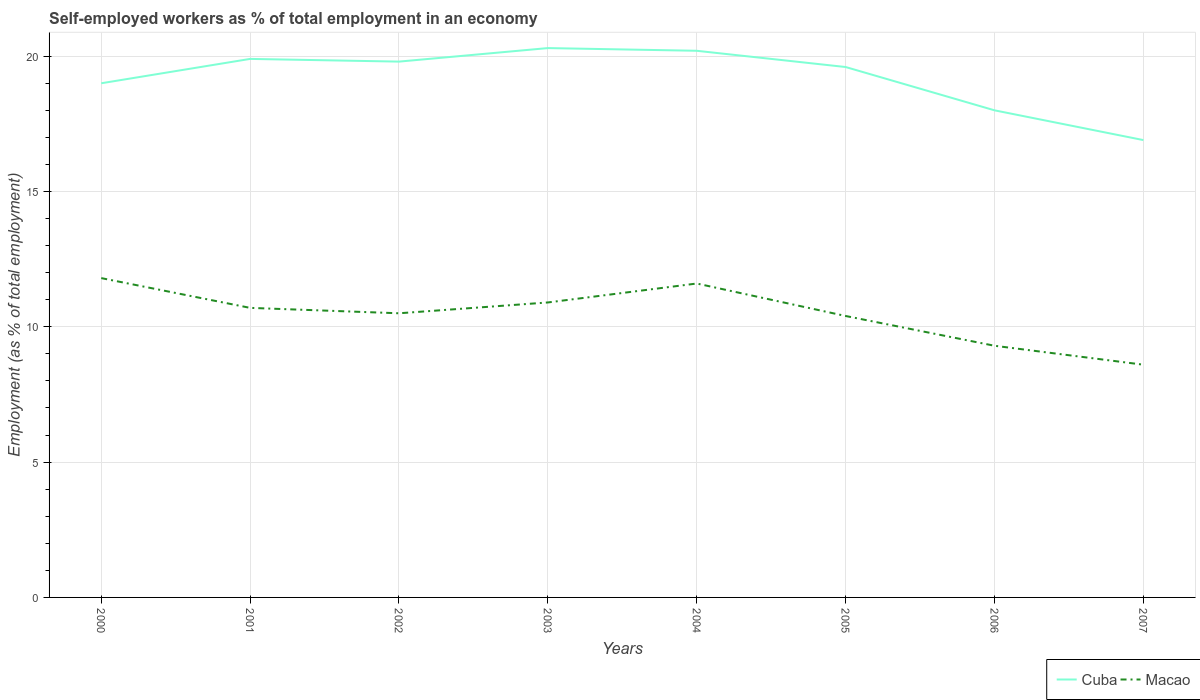How many different coloured lines are there?
Your response must be concise. 2. Does the line corresponding to Cuba intersect with the line corresponding to Macao?
Offer a terse response. No. Across all years, what is the maximum percentage of self-employed workers in Macao?
Your response must be concise. 8.6. In which year was the percentage of self-employed workers in Cuba maximum?
Make the answer very short. 2007. What is the total percentage of self-employed workers in Cuba in the graph?
Provide a succinct answer. -0.6. What is the difference between the highest and the second highest percentage of self-employed workers in Macao?
Ensure brevity in your answer.  3.2. Is the percentage of self-employed workers in Macao strictly greater than the percentage of self-employed workers in Cuba over the years?
Your answer should be compact. Yes. How many lines are there?
Offer a very short reply. 2. How many years are there in the graph?
Your response must be concise. 8. What is the difference between two consecutive major ticks on the Y-axis?
Your response must be concise. 5. How many legend labels are there?
Your answer should be compact. 2. What is the title of the graph?
Your answer should be very brief. Self-employed workers as % of total employment in an economy. What is the label or title of the Y-axis?
Your response must be concise. Employment (as % of total employment). What is the Employment (as % of total employment) of Macao in 2000?
Keep it short and to the point. 11.8. What is the Employment (as % of total employment) of Cuba in 2001?
Make the answer very short. 19.9. What is the Employment (as % of total employment) in Macao in 2001?
Give a very brief answer. 10.7. What is the Employment (as % of total employment) of Cuba in 2002?
Your response must be concise. 19.8. What is the Employment (as % of total employment) of Macao in 2002?
Your answer should be very brief. 10.5. What is the Employment (as % of total employment) in Cuba in 2003?
Your response must be concise. 20.3. What is the Employment (as % of total employment) of Macao in 2003?
Keep it short and to the point. 10.9. What is the Employment (as % of total employment) of Cuba in 2004?
Provide a succinct answer. 20.2. What is the Employment (as % of total employment) of Macao in 2004?
Provide a short and direct response. 11.6. What is the Employment (as % of total employment) in Cuba in 2005?
Your answer should be very brief. 19.6. What is the Employment (as % of total employment) in Macao in 2005?
Offer a very short reply. 10.4. What is the Employment (as % of total employment) in Macao in 2006?
Your answer should be very brief. 9.3. What is the Employment (as % of total employment) in Cuba in 2007?
Give a very brief answer. 16.9. What is the Employment (as % of total employment) of Macao in 2007?
Your response must be concise. 8.6. Across all years, what is the maximum Employment (as % of total employment) in Cuba?
Your response must be concise. 20.3. Across all years, what is the maximum Employment (as % of total employment) in Macao?
Ensure brevity in your answer.  11.8. Across all years, what is the minimum Employment (as % of total employment) of Cuba?
Give a very brief answer. 16.9. Across all years, what is the minimum Employment (as % of total employment) in Macao?
Ensure brevity in your answer.  8.6. What is the total Employment (as % of total employment) of Cuba in the graph?
Your response must be concise. 153.7. What is the total Employment (as % of total employment) of Macao in the graph?
Give a very brief answer. 83.8. What is the difference between the Employment (as % of total employment) of Cuba in 2000 and that in 2004?
Offer a terse response. -1.2. What is the difference between the Employment (as % of total employment) in Macao in 2000 and that in 2004?
Provide a short and direct response. 0.2. What is the difference between the Employment (as % of total employment) of Cuba in 2000 and that in 2007?
Offer a very short reply. 2.1. What is the difference between the Employment (as % of total employment) of Macao in 2001 and that in 2002?
Your answer should be compact. 0.2. What is the difference between the Employment (as % of total employment) in Cuba in 2001 and that in 2003?
Give a very brief answer. -0.4. What is the difference between the Employment (as % of total employment) in Macao in 2001 and that in 2003?
Your answer should be compact. -0.2. What is the difference between the Employment (as % of total employment) in Cuba in 2001 and that in 2004?
Offer a terse response. -0.3. What is the difference between the Employment (as % of total employment) in Macao in 2001 and that in 2004?
Ensure brevity in your answer.  -0.9. What is the difference between the Employment (as % of total employment) in Cuba in 2001 and that in 2006?
Offer a terse response. 1.9. What is the difference between the Employment (as % of total employment) in Cuba in 2001 and that in 2007?
Offer a terse response. 3. What is the difference between the Employment (as % of total employment) of Cuba in 2002 and that in 2004?
Offer a terse response. -0.4. What is the difference between the Employment (as % of total employment) in Cuba in 2002 and that in 2005?
Provide a short and direct response. 0.2. What is the difference between the Employment (as % of total employment) of Macao in 2002 and that in 2005?
Ensure brevity in your answer.  0.1. What is the difference between the Employment (as % of total employment) in Macao in 2002 and that in 2006?
Offer a very short reply. 1.2. What is the difference between the Employment (as % of total employment) in Macao in 2002 and that in 2007?
Your response must be concise. 1.9. What is the difference between the Employment (as % of total employment) of Cuba in 2003 and that in 2004?
Offer a terse response. 0.1. What is the difference between the Employment (as % of total employment) of Macao in 2003 and that in 2005?
Offer a terse response. 0.5. What is the difference between the Employment (as % of total employment) in Macao in 2003 and that in 2007?
Your answer should be compact. 2.3. What is the difference between the Employment (as % of total employment) of Macao in 2005 and that in 2006?
Your answer should be very brief. 1.1. What is the difference between the Employment (as % of total employment) of Cuba in 2005 and that in 2007?
Offer a terse response. 2.7. What is the difference between the Employment (as % of total employment) of Macao in 2005 and that in 2007?
Offer a very short reply. 1.8. What is the difference between the Employment (as % of total employment) of Cuba in 2000 and the Employment (as % of total employment) of Macao in 2001?
Ensure brevity in your answer.  8.3. What is the difference between the Employment (as % of total employment) in Cuba in 2000 and the Employment (as % of total employment) in Macao in 2002?
Ensure brevity in your answer.  8.5. What is the difference between the Employment (as % of total employment) of Cuba in 2000 and the Employment (as % of total employment) of Macao in 2005?
Offer a very short reply. 8.6. What is the difference between the Employment (as % of total employment) of Cuba in 2000 and the Employment (as % of total employment) of Macao in 2007?
Offer a terse response. 10.4. What is the difference between the Employment (as % of total employment) in Cuba in 2001 and the Employment (as % of total employment) in Macao in 2002?
Offer a very short reply. 9.4. What is the difference between the Employment (as % of total employment) in Cuba in 2001 and the Employment (as % of total employment) in Macao in 2003?
Make the answer very short. 9. What is the difference between the Employment (as % of total employment) in Cuba in 2001 and the Employment (as % of total employment) in Macao in 2004?
Your answer should be compact. 8.3. What is the difference between the Employment (as % of total employment) in Cuba in 2001 and the Employment (as % of total employment) in Macao in 2005?
Make the answer very short. 9.5. What is the difference between the Employment (as % of total employment) of Cuba in 2001 and the Employment (as % of total employment) of Macao in 2006?
Provide a short and direct response. 10.6. What is the difference between the Employment (as % of total employment) of Cuba in 2001 and the Employment (as % of total employment) of Macao in 2007?
Offer a very short reply. 11.3. What is the difference between the Employment (as % of total employment) of Cuba in 2002 and the Employment (as % of total employment) of Macao in 2006?
Give a very brief answer. 10.5. What is the difference between the Employment (as % of total employment) of Cuba in 2002 and the Employment (as % of total employment) of Macao in 2007?
Offer a terse response. 11.2. What is the difference between the Employment (as % of total employment) of Cuba in 2003 and the Employment (as % of total employment) of Macao in 2004?
Provide a succinct answer. 8.7. What is the difference between the Employment (as % of total employment) of Cuba in 2003 and the Employment (as % of total employment) of Macao in 2007?
Your answer should be very brief. 11.7. What is the difference between the Employment (as % of total employment) in Cuba in 2004 and the Employment (as % of total employment) in Macao in 2005?
Ensure brevity in your answer.  9.8. What is the difference between the Employment (as % of total employment) in Cuba in 2005 and the Employment (as % of total employment) in Macao in 2006?
Ensure brevity in your answer.  10.3. What is the difference between the Employment (as % of total employment) of Cuba in 2005 and the Employment (as % of total employment) of Macao in 2007?
Offer a terse response. 11. What is the difference between the Employment (as % of total employment) in Cuba in 2006 and the Employment (as % of total employment) in Macao in 2007?
Your response must be concise. 9.4. What is the average Employment (as % of total employment) in Cuba per year?
Make the answer very short. 19.21. What is the average Employment (as % of total employment) in Macao per year?
Your answer should be compact. 10.47. In the year 2000, what is the difference between the Employment (as % of total employment) of Cuba and Employment (as % of total employment) of Macao?
Keep it short and to the point. 7.2. In the year 2002, what is the difference between the Employment (as % of total employment) in Cuba and Employment (as % of total employment) in Macao?
Provide a succinct answer. 9.3. In the year 2003, what is the difference between the Employment (as % of total employment) in Cuba and Employment (as % of total employment) in Macao?
Your response must be concise. 9.4. In the year 2004, what is the difference between the Employment (as % of total employment) of Cuba and Employment (as % of total employment) of Macao?
Keep it short and to the point. 8.6. In the year 2006, what is the difference between the Employment (as % of total employment) of Cuba and Employment (as % of total employment) of Macao?
Offer a very short reply. 8.7. In the year 2007, what is the difference between the Employment (as % of total employment) of Cuba and Employment (as % of total employment) of Macao?
Provide a short and direct response. 8.3. What is the ratio of the Employment (as % of total employment) in Cuba in 2000 to that in 2001?
Make the answer very short. 0.95. What is the ratio of the Employment (as % of total employment) of Macao in 2000 to that in 2001?
Make the answer very short. 1.1. What is the ratio of the Employment (as % of total employment) in Cuba in 2000 to that in 2002?
Make the answer very short. 0.96. What is the ratio of the Employment (as % of total employment) of Macao in 2000 to that in 2002?
Offer a terse response. 1.12. What is the ratio of the Employment (as % of total employment) in Cuba in 2000 to that in 2003?
Provide a succinct answer. 0.94. What is the ratio of the Employment (as % of total employment) of Macao in 2000 to that in 2003?
Your answer should be very brief. 1.08. What is the ratio of the Employment (as % of total employment) in Cuba in 2000 to that in 2004?
Offer a terse response. 0.94. What is the ratio of the Employment (as % of total employment) of Macao in 2000 to that in 2004?
Make the answer very short. 1.02. What is the ratio of the Employment (as % of total employment) in Cuba in 2000 to that in 2005?
Make the answer very short. 0.97. What is the ratio of the Employment (as % of total employment) of Macao in 2000 to that in 2005?
Provide a short and direct response. 1.13. What is the ratio of the Employment (as % of total employment) in Cuba in 2000 to that in 2006?
Offer a terse response. 1.06. What is the ratio of the Employment (as % of total employment) in Macao in 2000 to that in 2006?
Provide a succinct answer. 1.27. What is the ratio of the Employment (as % of total employment) of Cuba in 2000 to that in 2007?
Your answer should be very brief. 1.12. What is the ratio of the Employment (as % of total employment) of Macao in 2000 to that in 2007?
Your answer should be very brief. 1.37. What is the ratio of the Employment (as % of total employment) in Cuba in 2001 to that in 2002?
Provide a short and direct response. 1.01. What is the ratio of the Employment (as % of total employment) in Macao in 2001 to that in 2002?
Offer a very short reply. 1.02. What is the ratio of the Employment (as % of total employment) of Cuba in 2001 to that in 2003?
Provide a short and direct response. 0.98. What is the ratio of the Employment (as % of total employment) in Macao in 2001 to that in 2003?
Make the answer very short. 0.98. What is the ratio of the Employment (as % of total employment) in Cuba in 2001 to that in 2004?
Provide a succinct answer. 0.99. What is the ratio of the Employment (as % of total employment) in Macao in 2001 to that in 2004?
Keep it short and to the point. 0.92. What is the ratio of the Employment (as % of total employment) in Cuba in 2001 to that in 2005?
Give a very brief answer. 1.02. What is the ratio of the Employment (as % of total employment) of Macao in 2001 to that in 2005?
Your response must be concise. 1.03. What is the ratio of the Employment (as % of total employment) in Cuba in 2001 to that in 2006?
Ensure brevity in your answer.  1.11. What is the ratio of the Employment (as % of total employment) in Macao in 2001 to that in 2006?
Your response must be concise. 1.15. What is the ratio of the Employment (as % of total employment) of Cuba in 2001 to that in 2007?
Give a very brief answer. 1.18. What is the ratio of the Employment (as % of total employment) in Macao in 2001 to that in 2007?
Your answer should be very brief. 1.24. What is the ratio of the Employment (as % of total employment) in Cuba in 2002 to that in 2003?
Your answer should be very brief. 0.98. What is the ratio of the Employment (as % of total employment) of Macao in 2002 to that in 2003?
Provide a short and direct response. 0.96. What is the ratio of the Employment (as % of total employment) of Cuba in 2002 to that in 2004?
Your response must be concise. 0.98. What is the ratio of the Employment (as % of total employment) of Macao in 2002 to that in 2004?
Provide a short and direct response. 0.91. What is the ratio of the Employment (as % of total employment) in Cuba in 2002 to that in 2005?
Your answer should be very brief. 1.01. What is the ratio of the Employment (as % of total employment) of Macao in 2002 to that in 2005?
Ensure brevity in your answer.  1.01. What is the ratio of the Employment (as % of total employment) of Cuba in 2002 to that in 2006?
Provide a succinct answer. 1.1. What is the ratio of the Employment (as % of total employment) of Macao in 2002 to that in 2006?
Ensure brevity in your answer.  1.13. What is the ratio of the Employment (as % of total employment) of Cuba in 2002 to that in 2007?
Offer a very short reply. 1.17. What is the ratio of the Employment (as % of total employment) in Macao in 2002 to that in 2007?
Give a very brief answer. 1.22. What is the ratio of the Employment (as % of total employment) of Cuba in 2003 to that in 2004?
Your answer should be compact. 1. What is the ratio of the Employment (as % of total employment) in Macao in 2003 to that in 2004?
Your answer should be very brief. 0.94. What is the ratio of the Employment (as % of total employment) in Cuba in 2003 to that in 2005?
Give a very brief answer. 1.04. What is the ratio of the Employment (as % of total employment) of Macao in 2003 to that in 2005?
Your response must be concise. 1.05. What is the ratio of the Employment (as % of total employment) in Cuba in 2003 to that in 2006?
Offer a very short reply. 1.13. What is the ratio of the Employment (as % of total employment) in Macao in 2003 to that in 2006?
Make the answer very short. 1.17. What is the ratio of the Employment (as % of total employment) of Cuba in 2003 to that in 2007?
Your answer should be compact. 1.2. What is the ratio of the Employment (as % of total employment) of Macao in 2003 to that in 2007?
Make the answer very short. 1.27. What is the ratio of the Employment (as % of total employment) of Cuba in 2004 to that in 2005?
Provide a succinct answer. 1.03. What is the ratio of the Employment (as % of total employment) in Macao in 2004 to that in 2005?
Give a very brief answer. 1.12. What is the ratio of the Employment (as % of total employment) of Cuba in 2004 to that in 2006?
Your response must be concise. 1.12. What is the ratio of the Employment (as % of total employment) of Macao in 2004 to that in 2006?
Provide a short and direct response. 1.25. What is the ratio of the Employment (as % of total employment) in Cuba in 2004 to that in 2007?
Your response must be concise. 1.2. What is the ratio of the Employment (as % of total employment) of Macao in 2004 to that in 2007?
Make the answer very short. 1.35. What is the ratio of the Employment (as % of total employment) in Cuba in 2005 to that in 2006?
Ensure brevity in your answer.  1.09. What is the ratio of the Employment (as % of total employment) in Macao in 2005 to that in 2006?
Offer a terse response. 1.12. What is the ratio of the Employment (as % of total employment) of Cuba in 2005 to that in 2007?
Your answer should be compact. 1.16. What is the ratio of the Employment (as % of total employment) in Macao in 2005 to that in 2007?
Offer a very short reply. 1.21. What is the ratio of the Employment (as % of total employment) of Cuba in 2006 to that in 2007?
Provide a succinct answer. 1.07. What is the ratio of the Employment (as % of total employment) of Macao in 2006 to that in 2007?
Your answer should be compact. 1.08. What is the difference between the highest and the second highest Employment (as % of total employment) in Cuba?
Your answer should be compact. 0.1. What is the difference between the highest and the second highest Employment (as % of total employment) in Macao?
Make the answer very short. 0.2. What is the difference between the highest and the lowest Employment (as % of total employment) in Macao?
Ensure brevity in your answer.  3.2. 